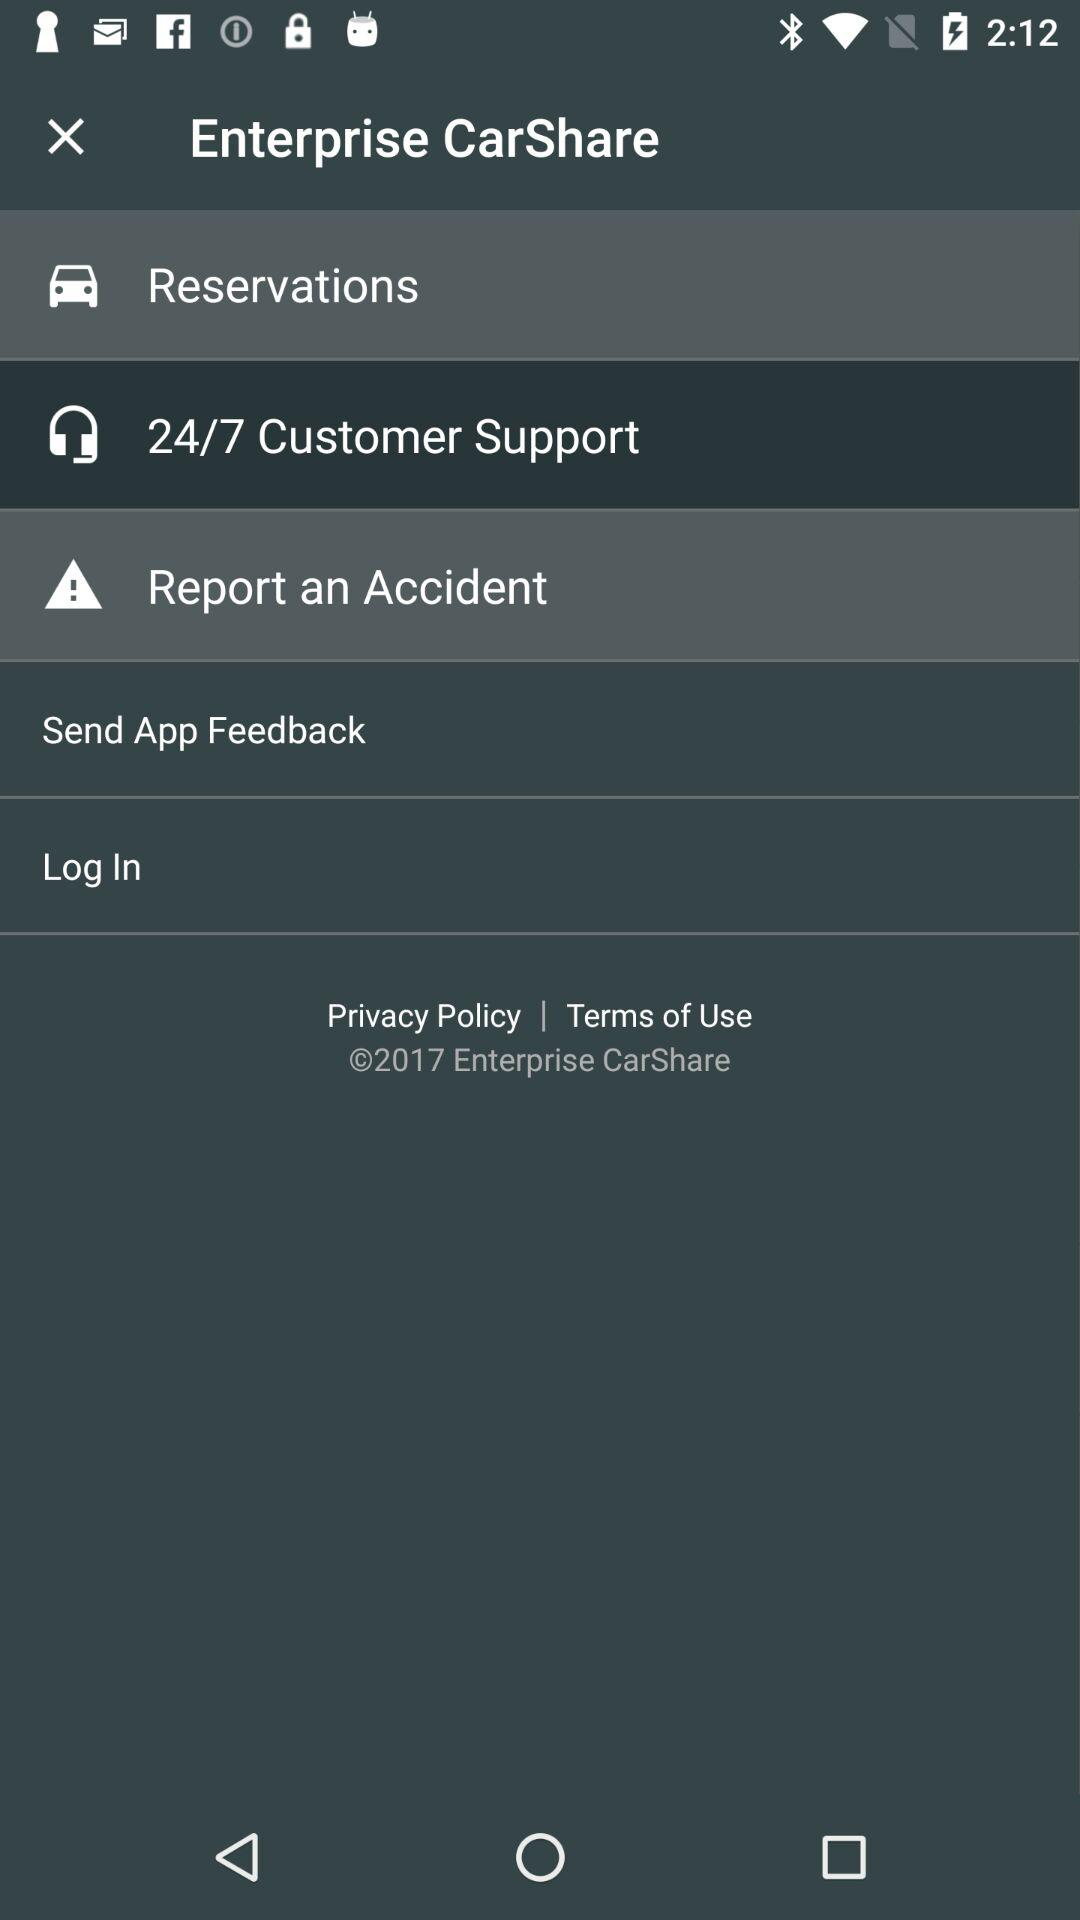How is customer support contacted?
When the provided information is insufficient, respond with <no answer>. <no answer> 